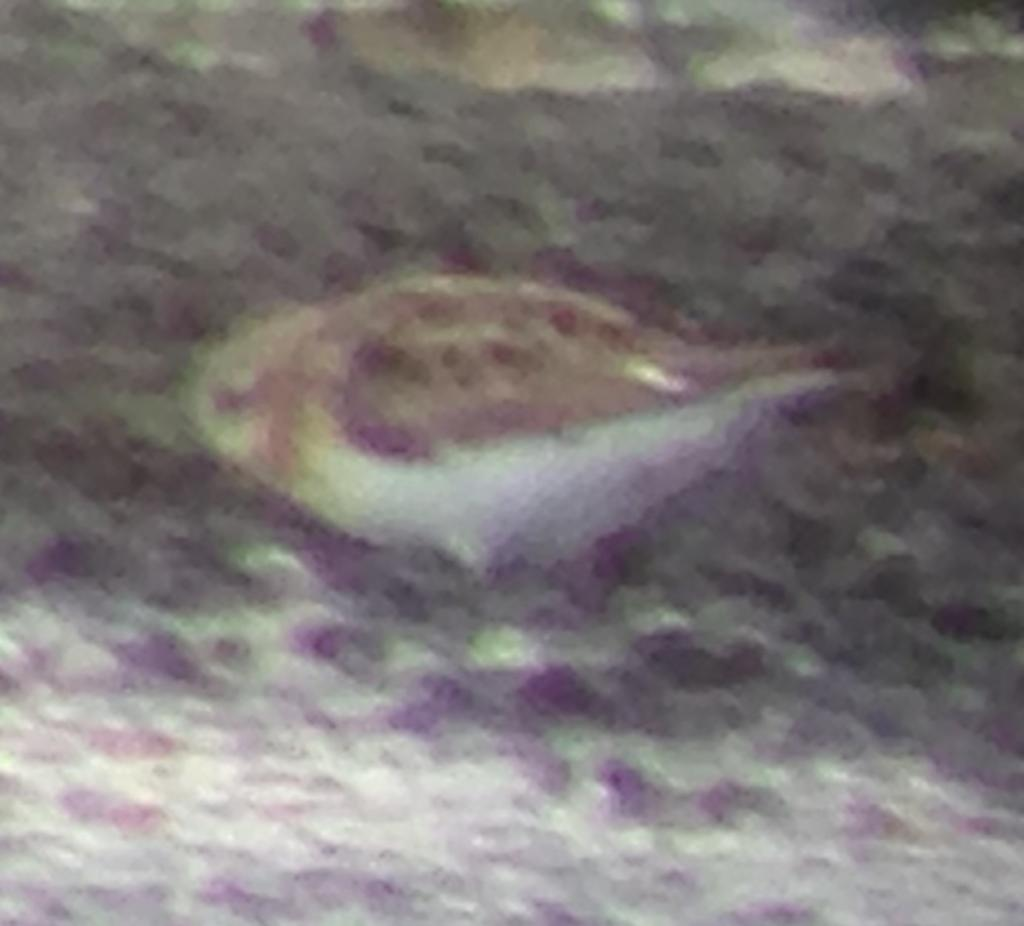What is the main subject of the image? There is a fish in the image. Where is the fish located? The fish is in the water. How far away is the poisonous fang from the fish in the image? There is no poisonous fang present in the image, as it only features a fish in the water. 